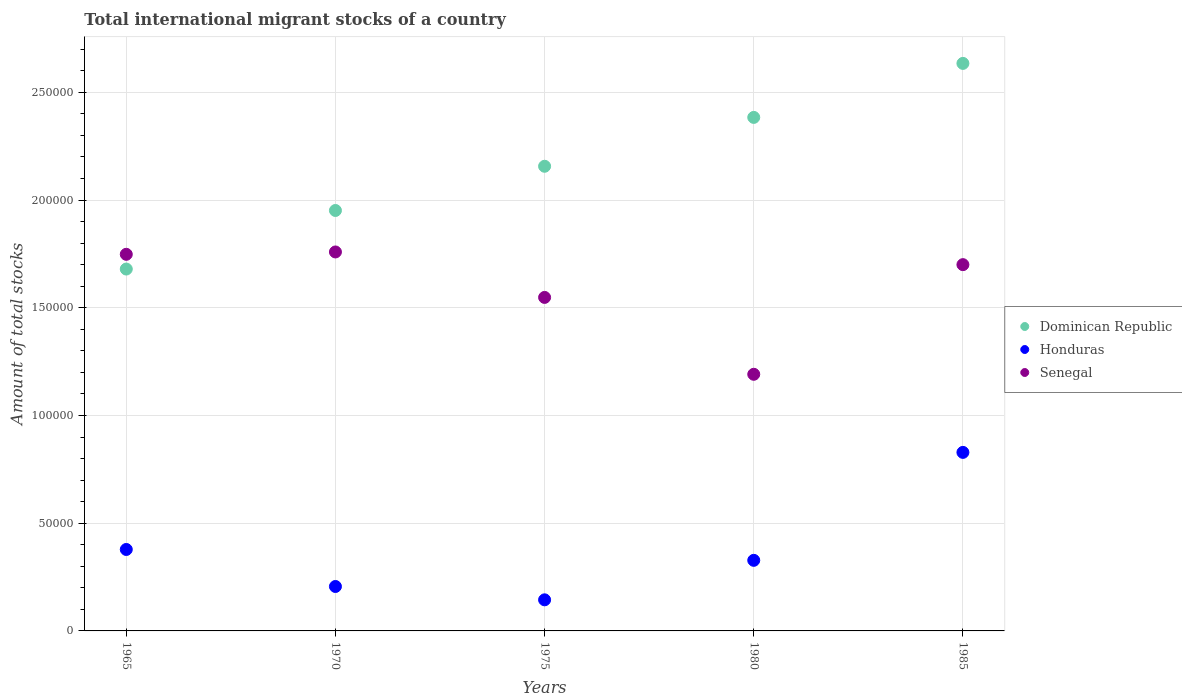How many different coloured dotlines are there?
Provide a short and direct response. 3. What is the amount of total stocks in in Honduras in 1975?
Make the answer very short. 1.44e+04. Across all years, what is the maximum amount of total stocks in in Dominican Republic?
Give a very brief answer. 2.63e+05. Across all years, what is the minimum amount of total stocks in in Honduras?
Your response must be concise. 1.44e+04. What is the total amount of total stocks in in Dominican Republic in the graph?
Make the answer very short. 1.08e+06. What is the difference between the amount of total stocks in in Senegal in 1980 and that in 1985?
Provide a succinct answer. -5.09e+04. What is the difference between the amount of total stocks in in Senegal in 1970 and the amount of total stocks in in Honduras in 1965?
Your answer should be compact. 1.38e+05. What is the average amount of total stocks in in Senegal per year?
Your response must be concise. 1.59e+05. In the year 1975, what is the difference between the amount of total stocks in in Senegal and amount of total stocks in in Honduras?
Your answer should be very brief. 1.40e+05. In how many years, is the amount of total stocks in in Dominican Republic greater than 170000?
Give a very brief answer. 4. What is the ratio of the amount of total stocks in in Senegal in 1970 to that in 1980?
Ensure brevity in your answer.  1.48. Is the difference between the amount of total stocks in in Senegal in 1965 and 1975 greater than the difference between the amount of total stocks in in Honduras in 1965 and 1975?
Offer a terse response. No. What is the difference between the highest and the second highest amount of total stocks in in Senegal?
Your answer should be very brief. 1093. What is the difference between the highest and the lowest amount of total stocks in in Senegal?
Your answer should be very brief. 5.68e+04. Does the amount of total stocks in in Honduras monotonically increase over the years?
Your response must be concise. No. Is the amount of total stocks in in Honduras strictly greater than the amount of total stocks in in Senegal over the years?
Your answer should be very brief. No. Is the amount of total stocks in in Honduras strictly less than the amount of total stocks in in Senegal over the years?
Provide a short and direct response. Yes. How many dotlines are there?
Offer a terse response. 3. Are the values on the major ticks of Y-axis written in scientific E-notation?
Your answer should be compact. No. Does the graph contain any zero values?
Your answer should be compact. No. Does the graph contain grids?
Your answer should be compact. Yes. Where does the legend appear in the graph?
Offer a terse response. Center right. How many legend labels are there?
Keep it short and to the point. 3. What is the title of the graph?
Your answer should be compact. Total international migrant stocks of a country. Does "Bahamas" appear as one of the legend labels in the graph?
Give a very brief answer. No. What is the label or title of the Y-axis?
Ensure brevity in your answer.  Amount of total stocks. What is the Amount of total stocks in Dominican Republic in 1965?
Your answer should be very brief. 1.68e+05. What is the Amount of total stocks of Honduras in 1965?
Provide a succinct answer. 3.78e+04. What is the Amount of total stocks in Senegal in 1965?
Make the answer very short. 1.75e+05. What is the Amount of total stocks in Dominican Republic in 1970?
Your answer should be compact. 1.95e+05. What is the Amount of total stocks in Honduras in 1970?
Your response must be concise. 2.06e+04. What is the Amount of total stocks in Senegal in 1970?
Give a very brief answer. 1.76e+05. What is the Amount of total stocks of Dominican Republic in 1975?
Your answer should be very brief. 2.16e+05. What is the Amount of total stocks of Honduras in 1975?
Ensure brevity in your answer.  1.44e+04. What is the Amount of total stocks of Senegal in 1975?
Provide a succinct answer. 1.55e+05. What is the Amount of total stocks in Dominican Republic in 1980?
Your answer should be compact. 2.38e+05. What is the Amount of total stocks of Honduras in 1980?
Give a very brief answer. 3.28e+04. What is the Amount of total stocks of Senegal in 1980?
Give a very brief answer. 1.19e+05. What is the Amount of total stocks in Dominican Republic in 1985?
Give a very brief answer. 2.63e+05. What is the Amount of total stocks of Honduras in 1985?
Your answer should be very brief. 8.29e+04. What is the Amount of total stocks of Senegal in 1985?
Make the answer very short. 1.70e+05. Across all years, what is the maximum Amount of total stocks in Dominican Republic?
Your answer should be compact. 2.63e+05. Across all years, what is the maximum Amount of total stocks in Honduras?
Provide a short and direct response. 8.29e+04. Across all years, what is the maximum Amount of total stocks in Senegal?
Provide a succinct answer. 1.76e+05. Across all years, what is the minimum Amount of total stocks of Dominican Republic?
Give a very brief answer. 1.68e+05. Across all years, what is the minimum Amount of total stocks of Honduras?
Your answer should be very brief. 1.44e+04. Across all years, what is the minimum Amount of total stocks in Senegal?
Give a very brief answer. 1.19e+05. What is the total Amount of total stocks of Dominican Republic in the graph?
Keep it short and to the point. 1.08e+06. What is the total Amount of total stocks of Honduras in the graph?
Ensure brevity in your answer.  1.89e+05. What is the total Amount of total stocks in Senegal in the graph?
Your answer should be very brief. 7.95e+05. What is the difference between the Amount of total stocks of Dominican Republic in 1965 and that in 1970?
Make the answer very short. -2.72e+04. What is the difference between the Amount of total stocks of Honduras in 1965 and that in 1970?
Keep it short and to the point. 1.72e+04. What is the difference between the Amount of total stocks of Senegal in 1965 and that in 1970?
Ensure brevity in your answer.  -1093. What is the difference between the Amount of total stocks in Dominican Republic in 1965 and that in 1975?
Offer a terse response. -4.77e+04. What is the difference between the Amount of total stocks in Honduras in 1965 and that in 1975?
Provide a short and direct response. 2.34e+04. What is the difference between the Amount of total stocks in Senegal in 1965 and that in 1975?
Provide a succinct answer. 2.00e+04. What is the difference between the Amount of total stocks in Dominican Republic in 1965 and that in 1980?
Make the answer very short. -7.04e+04. What is the difference between the Amount of total stocks of Honduras in 1965 and that in 1980?
Offer a very short reply. 5040. What is the difference between the Amount of total stocks of Senegal in 1965 and that in 1980?
Provide a short and direct response. 5.57e+04. What is the difference between the Amount of total stocks in Dominican Republic in 1965 and that in 1985?
Keep it short and to the point. -9.55e+04. What is the difference between the Amount of total stocks of Honduras in 1965 and that in 1985?
Your answer should be compact. -4.51e+04. What is the difference between the Amount of total stocks of Senegal in 1965 and that in 1985?
Make the answer very short. 4798. What is the difference between the Amount of total stocks of Dominican Republic in 1970 and that in 1975?
Provide a short and direct response. -2.05e+04. What is the difference between the Amount of total stocks in Honduras in 1970 and that in 1975?
Give a very brief answer. 6191. What is the difference between the Amount of total stocks in Senegal in 1970 and that in 1975?
Give a very brief answer. 2.11e+04. What is the difference between the Amount of total stocks of Dominican Republic in 1970 and that in 1980?
Offer a very short reply. -4.32e+04. What is the difference between the Amount of total stocks in Honduras in 1970 and that in 1980?
Ensure brevity in your answer.  -1.21e+04. What is the difference between the Amount of total stocks in Senegal in 1970 and that in 1980?
Provide a succinct answer. 5.68e+04. What is the difference between the Amount of total stocks of Dominican Republic in 1970 and that in 1985?
Make the answer very short. -6.83e+04. What is the difference between the Amount of total stocks of Honduras in 1970 and that in 1985?
Give a very brief answer. -6.22e+04. What is the difference between the Amount of total stocks of Senegal in 1970 and that in 1985?
Your answer should be compact. 5891. What is the difference between the Amount of total stocks in Dominican Republic in 1975 and that in 1980?
Your answer should be compact. -2.27e+04. What is the difference between the Amount of total stocks of Honduras in 1975 and that in 1980?
Provide a short and direct response. -1.83e+04. What is the difference between the Amount of total stocks in Senegal in 1975 and that in 1980?
Keep it short and to the point. 3.57e+04. What is the difference between the Amount of total stocks of Dominican Republic in 1975 and that in 1985?
Keep it short and to the point. -4.78e+04. What is the difference between the Amount of total stocks of Honduras in 1975 and that in 1985?
Ensure brevity in your answer.  -6.84e+04. What is the difference between the Amount of total stocks in Senegal in 1975 and that in 1985?
Keep it short and to the point. -1.52e+04. What is the difference between the Amount of total stocks in Dominican Republic in 1980 and that in 1985?
Your answer should be very brief. -2.51e+04. What is the difference between the Amount of total stocks of Honduras in 1980 and that in 1985?
Offer a very short reply. -5.01e+04. What is the difference between the Amount of total stocks in Senegal in 1980 and that in 1985?
Provide a short and direct response. -5.09e+04. What is the difference between the Amount of total stocks of Dominican Republic in 1965 and the Amount of total stocks of Honduras in 1970?
Keep it short and to the point. 1.47e+05. What is the difference between the Amount of total stocks in Dominican Republic in 1965 and the Amount of total stocks in Senegal in 1970?
Keep it short and to the point. -7936. What is the difference between the Amount of total stocks in Honduras in 1965 and the Amount of total stocks in Senegal in 1970?
Your answer should be very brief. -1.38e+05. What is the difference between the Amount of total stocks in Dominican Republic in 1965 and the Amount of total stocks in Honduras in 1975?
Keep it short and to the point. 1.54e+05. What is the difference between the Amount of total stocks of Dominican Republic in 1965 and the Amount of total stocks of Senegal in 1975?
Ensure brevity in your answer.  1.32e+04. What is the difference between the Amount of total stocks in Honduras in 1965 and the Amount of total stocks in Senegal in 1975?
Make the answer very short. -1.17e+05. What is the difference between the Amount of total stocks of Dominican Republic in 1965 and the Amount of total stocks of Honduras in 1980?
Your response must be concise. 1.35e+05. What is the difference between the Amount of total stocks in Dominican Republic in 1965 and the Amount of total stocks in Senegal in 1980?
Ensure brevity in your answer.  4.89e+04. What is the difference between the Amount of total stocks in Honduras in 1965 and the Amount of total stocks in Senegal in 1980?
Ensure brevity in your answer.  -8.13e+04. What is the difference between the Amount of total stocks in Dominican Republic in 1965 and the Amount of total stocks in Honduras in 1985?
Offer a very short reply. 8.51e+04. What is the difference between the Amount of total stocks in Dominican Republic in 1965 and the Amount of total stocks in Senegal in 1985?
Give a very brief answer. -2045. What is the difference between the Amount of total stocks of Honduras in 1965 and the Amount of total stocks of Senegal in 1985?
Your response must be concise. -1.32e+05. What is the difference between the Amount of total stocks in Dominican Republic in 1970 and the Amount of total stocks in Honduras in 1975?
Your answer should be compact. 1.81e+05. What is the difference between the Amount of total stocks of Dominican Republic in 1970 and the Amount of total stocks of Senegal in 1975?
Give a very brief answer. 4.04e+04. What is the difference between the Amount of total stocks in Honduras in 1970 and the Amount of total stocks in Senegal in 1975?
Give a very brief answer. -1.34e+05. What is the difference between the Amount of total stocks of Dominican Republic in 1970 and the Amount of total stocks of Honduras in 1980?
Your answer should be very brief. 1.62e+05. What is the difference between the Amount of total stocks in Dominican Republic in 1970 and the Amount of total stocks in Senegal in 1980?
Your response must be concise. 7.60e+04. What is the difference between the Amount of total stocks in Honduras in 1970 and the Amount of total stocks in Senegal in 1980?
Offer a terse response. -9.85e+04. What is the difference between the Amount of total stocks in Dominican Republic in 1970 and the Amount of total stocks in Honduras in 1985?
Give a very brief answer. 1.12e+05. What is the difference between the Amount of total stocks in Dominican Republic in 1970 and the Amount of total stocks in Senegal in 1985?
Your answer should be compact. 2.51e+04. What is the difference between the Amount of total stocks in Honduras in 1970 and the Amount of total stocks in Senegal in 1985?
Ensure brevity in your answer.  -1.49e+05. What is the difference between the Amount of total stocks of Dominican Republic in 1975 and the Amount of total stocks of Honduras in 1980?
Offer a terse response. 1.83e+05. What is the difference between the Amount of total stocks of Dominican Republic in 1975 and the Amount of total stocks of Senegal in 1980?
Give a very brief answer. 9.66e+04. What is the difference between the Amount of total stocks of Honduras in 1975 and the Amount of total stocks of Senegal in 1980?
Your response must be concise. -1.05e+05. What is the difference between the Amount of total stocks in Dominican Republic in 1975 and the Amount of total stocks in Honduras in 1985?
Provide a short and direct response. 1.33e+05. What is the difference between the Amount of total stocks of Dominican Republic in 1975 and the Amount of total stocks of Senegal in 1985?
Give a very brief answer. 4.57e+04. What is the difference between the Amount of total stocks in Honduras in 1975 and the Amount of total stocks in Senegal in 1985?
Give a very brief answer. -1.56e+05. What is the difference between the Amount of total stocks of Dominican Republic in 1980 and the Amount of total stocks of Honduras in 1985?
Offer a very short reply. 1.56e+05. What is the difference between the Amount of total stocks in Dominican Republic in 1980 and the Amount of total stocks in Senegal in 1985?
Give a very brief answer. 6.83e+04. What is the difference between the Amount of total stocks of Honduras in 1980 and the Amount of total stocks of Senegal in 1985?
Provide a short and direct response. -1.37e+05. What is the average Amount of total stocks in Dominican Republic per year?
Your answer should be very brief. 2.16e+05. What is the average Amount of total stocks in Honduras per year?
Your answer should be very brief. 3.77e+04. What is the average Amount of total stocks of Senegal per year?
Provide a short and direct response. 1.59e+05. In the year 1965, what is the difference between the Amount of total stocks of Dominican Republic and Amount of total stocks of Honduras?
Your answer should be very brief. 1.30e+05. In the year 1965, what is the difference between the Amount of total stocks of Dominican Republic and Amount of total stocks of Senegal?
Your answer should be very brief. -6843. In the year 1965, what is the difference between the Amount of total stocks of Honduras and Amount of total stocks of Senegal?
Provide a short and direct response. -1.37e+05. In the year 1970, what is the difference between the Amount of total stocks in Dominican Republic and Amount of total stocks in Honduras?
Provide a short and direct response. 1.75e+05. In the year 1970, what is the difference between the Amount of total stocks of Dominican Republic and Amount of total stocks of Senegal?
Keep it short and to the point. 1.92e+04. In the year 1970, what is the difference between the Amount of total stocks of Honduras and Amount of total stocks of Senegal?
Your answer should be very brief. -1.55e+05. In the year 1975, what is the difference between the Amount of total stocks in Dominican Republic and Amount of total stocks in Honduras?
Offer a very short reply. 2.01e+05. In the year 1975, what is the difference between the Amount of total stocks in Dominican Republic and Amount of total stocks in Senegal?
Offer a terse response. 6.09e+04. In the year 1975, what is the difference between the Amount of total stocks of Honduras and Amount of total stocks of Senegal?
Your answer should be compact. -1.40e+05. In the year 1980, what is the difference between the Amount of total stocks in Dominican Republic and Amount of total stocks in Honduras?
Give a very brief answer. 2.06e+05. In the year 1980, what is the difference between the Amount of total stocks of Dominican Republic and Amount of total stocks of Senegal?
Offer a terse response. 1.19e+05. In the year 1980, what is the difference between the Amount of total stocks in Honduras and Amount of total stocks in Senegal?
Offer a terse response. -8.64e+04. In the year 1985, what is the difference between the Amount of total stocks of Dominican Republic and Amount of total stocks of Honduras?
Offer a terse response. 1.81e+05. In the year 1985, what is the difference between the Amount of total stocks in Dominican Republic and Amount of total stocks in Senegal?
Give a very brief answer. 9.34e+04. In the year 1985, what is the difference between the Amount of total stocks in Honduras and Amount of total stocks in Senegal?
Make the answer very short. -8.72e+04. What is the ratio of the Amount of total stocks in Dominican Republic in 1965 to that in 1970?
Provide a short and direct response. 0.86. What is the ratio of the Amount of total stocks of Honduras in 1965 to that in 1970?
Make the answer very short. 1.83. What is the ratio of the Amount of total stocks in Dominican Republic in 1965 to that in 1975?
Provide a succinct answer. 0.78. What is the ratio of the Amount of total stocks of Honduras in 1965 to that in 1975?
Offer a terse response. 2.62. What is the ratio of the Amount of total stocks of Senegal in 1965 to that in 1975?
Your answer should be very brief. 1.13. What is the ratio of the Amount of total stocks in Dominican Republic in 1965 to that in 1980?
Your answer should be compact. 0.7. What is the ratio of the Amount of total stocks of Honduras in 1965 to that in 1980?
Your answer should be compact. 1.15. What is the ratio of the Amount of total stocks of Senegal in 1965 to that in 1980?
Your answer should be compact. 1.47. What is the ratio of the Amount of total stocks in Dominican Republic in 1965 to that in 1985?
Offer a terse response. 0.64. What is the ratio of the Amount of total stocks in Honduras in 1965 to that in 1985?
Your answer should be compact. 0.46. What is the ratio of the Amount of total stocks of Senegal in 1965 to that in 1985?
Make the answer very short. 1.03. What is the ratio of the Amount of total stocks in Dominican Republic in 1970 to that in 1975?
Your answer should be compact. 0.9. What is the ratio of the Amount of total stocks of Honduras in 1970 to that in 1975?
Give a very brief answer. 1.43. What is the ratio of the Amount of total stocks in Senegal in 1970 to that in 1975?
Your response must be concise. 1.14. What is the ratio of the Amount of total stocks in Dominican Republic in 1970 to that in 1980?
Ensure brevity in your answer.  0.82. What is the ratio of the Amount of total stocks in Honduras in 1970 to that in 1980?
Offer a very short reply. 0.63. What is the ratio of the Amount of total stocks of Senegal in 1970 to that in 1980?
Make the answer very short. 1.48. What is the ratio of the Amount of total stocks of Dominican Republic in 1970 to that in 1985?
Offer a very short reply. 0.74. What is the ratio of the Amount of total stocks in Honduras in 1970 to that in 1985?
Your answer should be compact. 0.25. What is the ratio of the Amount of total stocks in Senegal in 1970 to that in 1985?
Make the answer very short. 1.03. What is the ratio of the Amount of total stocks in Dominican Republic in 1975 to that in 1980?
Your response must be concise. 0.9. What is the ratio of the Amount of total stocks in Honduras in 1975 to that in 1980?
Your response must be concise. 0.44. What is the ratio of the Amount of total stocks in Senegal in 1975 to that in 1980?
Provide a short and direct response. 1.3. What is the ratio of the Amount of total stocks in Dominican Republic in 1975 to that in 1985?
Keep it short and to the point. 0.82. What is the ratio of the Amount of total stocks of Honduras in 1975 to that in 1985?
Ensure brevity in your answer.  0.17. What is the ratio of the Amount of total stocks in Senegal in 1975 to that in 1985?
Ensure brevity in your answer.  0.91. What is the ratio of the Amount of total stocks in Dominican Republic in 1980 to that in 1985?
Keep it short and to the point. 0.9. What is the ratio of the Amount of total stocks of Honduras in 1980 to that in 1985?
Make the answer very short. 0.4. What is the ratio of the Amount of total stocks in Senegal in 1980 to that in 1985?
Give a very brief answer. 0.7. What is the difference between the highest and the second highest Amount of total stocks of Dominican Republic?
Keep it short and to the point. 2.51e+04. What is the difference between the highest and the second highest Amount of total stocks in Honduras?
Keep it short and to the point. 4.51e+04. What is the difference between the highest and the second highest Amount of total stocks in Senegal?
Ensure brevity in your answer.  1093. What is the difference between the highest and the lowest Amount of total stocks in Dominican Republic?
Offer a very short reply. 9.55e+04. What is the difference between the highest and the lowest Amount of total stocks in Honduras?
Your response must be concise. 6.84e+04. What is the difference between the highest and the lowest Amount of total stocks of Senegal?
Provide a succinct answer. 5.68e+04. 